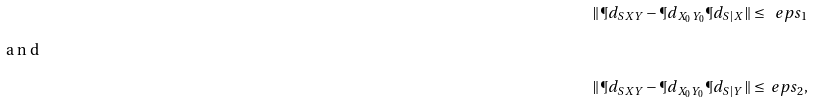<formula> <loc_0><loc_0><loc_500><loc_500>\| \P d _ { S X Y } - \P d _ { X _ { 0 } Y _ { 0 } } \P d _ { S | X } \| \leq \ e p s _ { 1 } \intertext { a n d } \| \P d _ { S X Y } - \P d _ { X _ { 0 } Y _ { 0 } } \P d _ { S | Y } \| \leq \ e p s _ { 2 } ,</formula> 